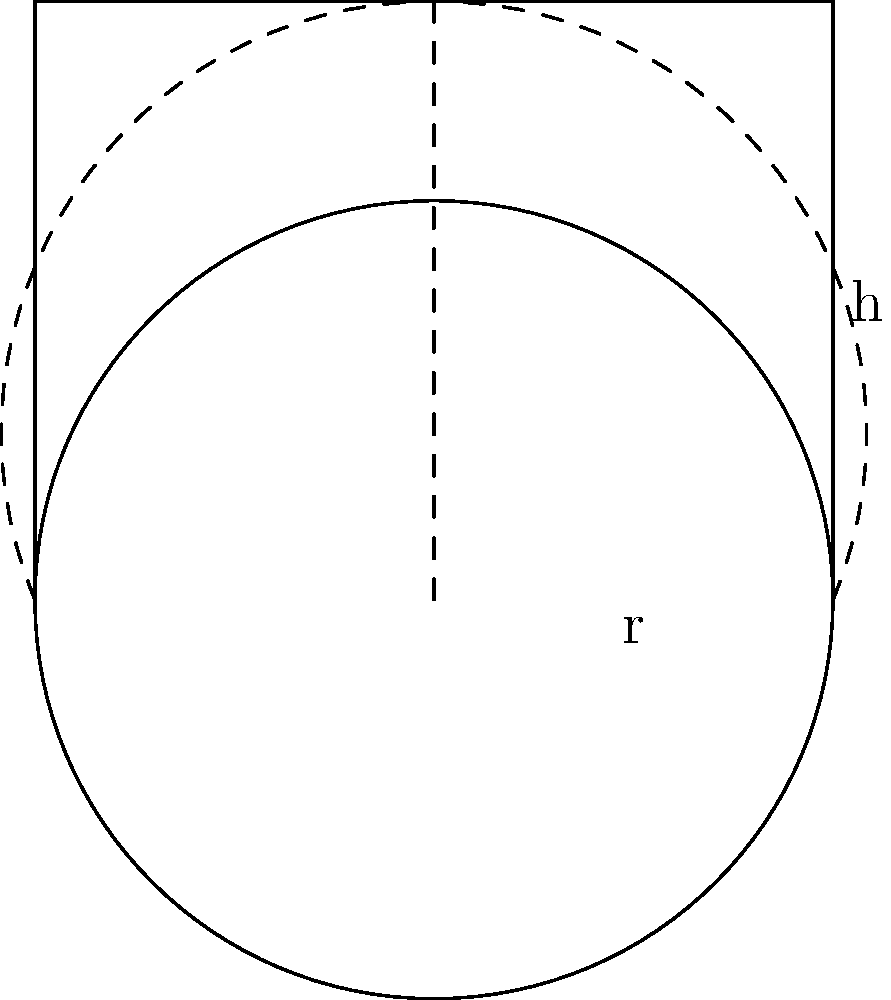As a bakery owner, you want to calculate the volume of a new cylindrical cake tin. The tin has a radius of 10 cm and a height of 15 cm. What is the volume of the cake tin in cubic centimeters? Use $\pi \approx 3.14$ for your calculation. To calculate the volume of a cylindrical cake tin, we use the formula:

$$V = \pi r^2 h$$

Where:
$V$ = volume
$r$ = radius
$h$ = height
$\pi \approx 3.14$

Given:
$r = 10$ cm
$h = 15$ cm

Let's substitute these values into the formula:

$$\begin{align}
V &= \pi r^2 h \\
&= 3.14 \times (10 \text{ cm})^2 \times 15 \text{ cm} \\
&= 3.14 \times 100 \text{ cm}^2 \times 15 \text{ cm} \\
&= 4,710 \text{ cm}^3
\end{align}$$

Therefore, the volume of the cylindrical cake tin is 4,710 cubic centimeters.
Answer: 4,710 cm³ 